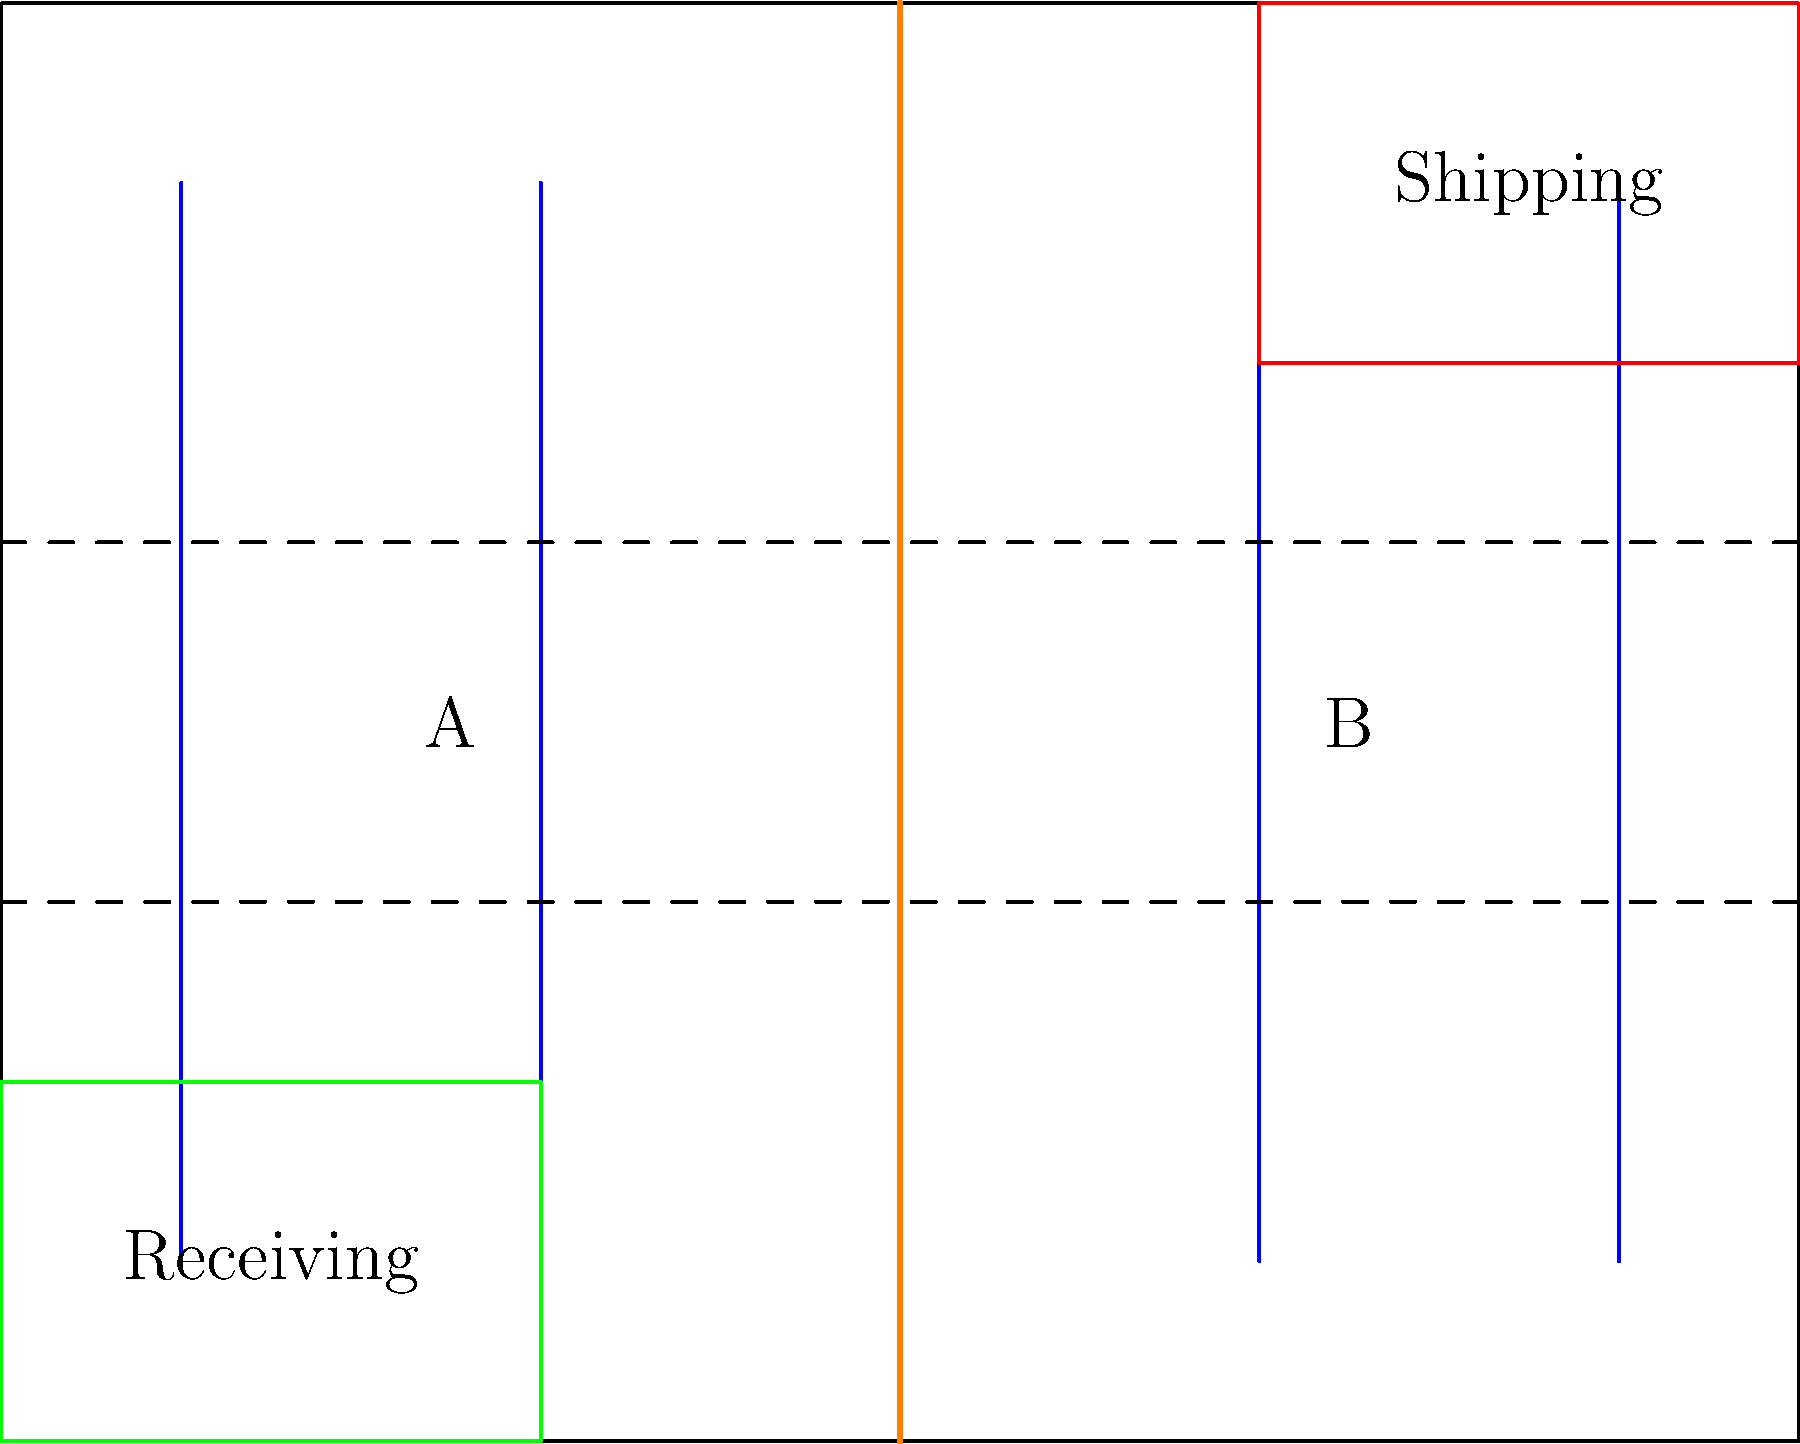Based on the warehouse floor plan shown, which layout modification would most likely improve the efficiency of inventory management for your small business in Gresik Regency? 

A) Increase the number of shelving units in area A
B) Expand the receiving area
C) Relocate the shipping area to be adjacent to the receiving area
D) Widen the main aisle (orange line) To answer this question, we need to consider the principles of efficient warehouse layout and inventory management, particularly in the context of a small business in Gresik Regency, East Java. Let's analyze each option:

1. Increasing shelving units in area A:
   This would increase storage capacity but may not necessarily improve efficiency.

2. Expanding the receiving area:
   While this might speed up the receiving process, it doesn't address the overall flow of goods.

3. Relocating the shipping area adjacent to the receiving area:
   This option would significantly improve the efficiency of inventory management by:
   a) Reducing the distance goods need to travel from reception to shipping
   b) Centralizing the inbound and outbound operations
   c) Minimizing cross-warehouse traffic
   d) Potentially reducing labor costs and time spent on material handling

4. Widening the main aisle:
   This might improve forklift maneuverability but doesn't address the core issue of inventory flow.

For a small business, minimizing the distance between receiving and shipping areas is crucial for efficient operations. This layout modification would streamline the flow of goods, reduce handling time, and potentially allow for better inventory control.
Answer: C) Relocate the shipping area to be adjacent to the receiving area 